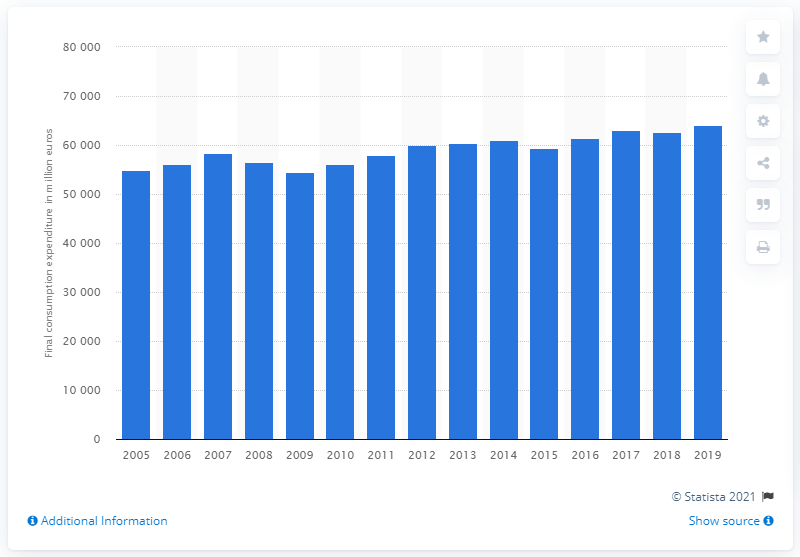Mention a couple of crucial points in this snapshot. The total spending on clothing in Germany in 2019 was 64,026. 